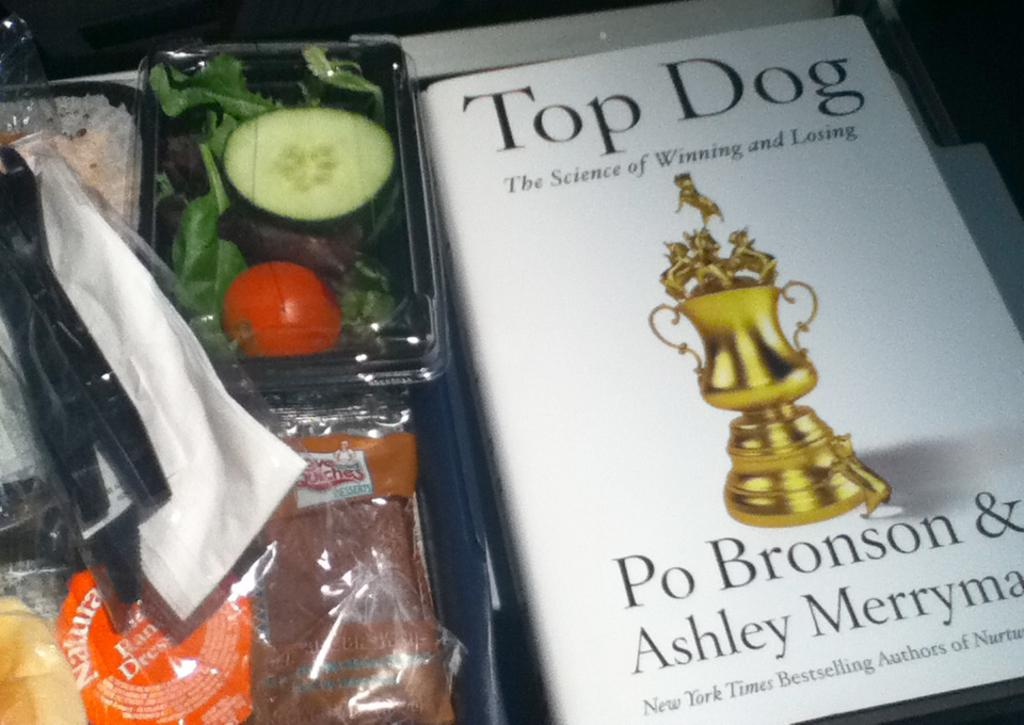<image>
Provide a brief description of the given image. A book with a trophy on the cover that is about the science of winning and losing. 